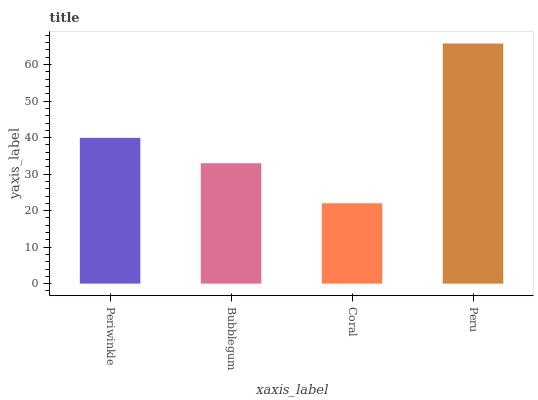Is Coral the minimum?
Answer yes or no. Yes. Is Peru the maximum?
Answer yes or no. Yes. Is Bubblegum the minimum?
Answer yes or no. No. Is Bubblegum the maximum?
Answer yes or no. No. Is Periwinkle greater than Bubblegum?
Answer yes or no. Yes. Is Bubblegum less than Periwinkle?
Answer yes or no. Yes. Is Bubblegum greater than Periwinkle?
Answer yes or no. No. Is Periwinkle less than Bubblegum?
Answer yes or no. No. Is Periwinkle the high median?
Answer yes or no. Yes. Is Bubblegum the low median?
Answer yes or no. Yes. Is Bubblegum the high median?
Answer yes or no. No. Is Coral the low median?
Answer yes or no. No. 